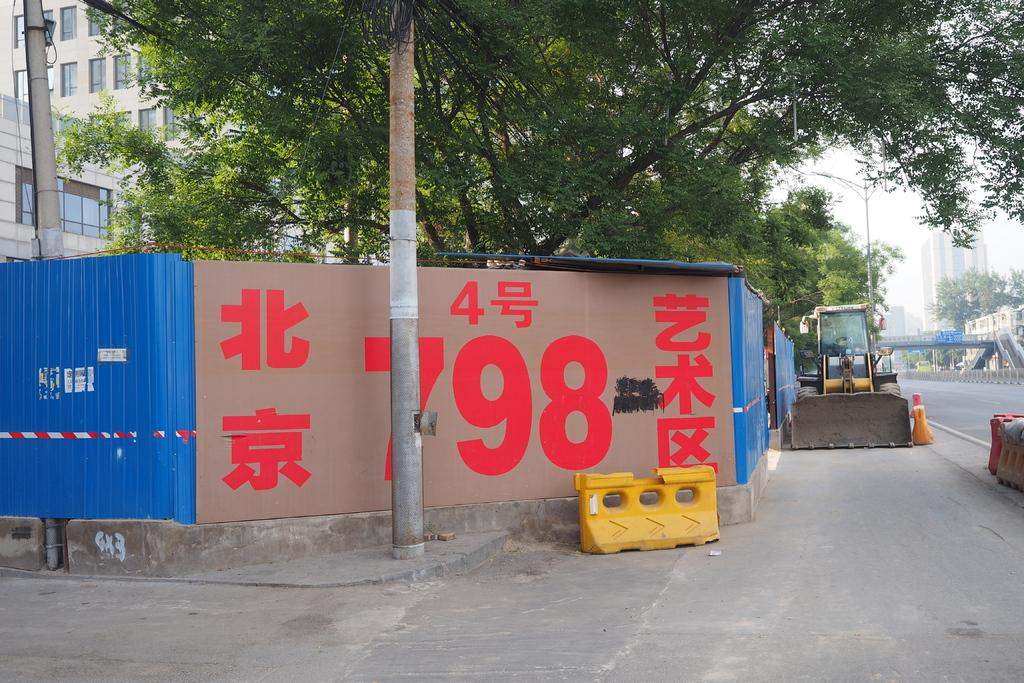<image>
Present a compact description of the photo's key features. the word 798 that is on a wall 